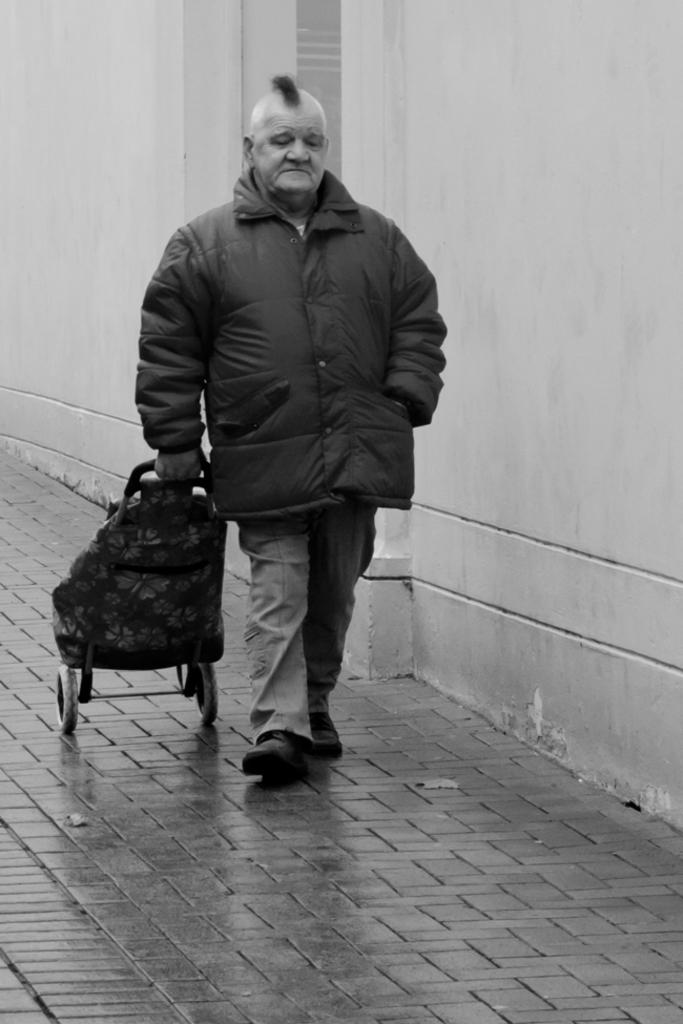What is the main subject of the image? There is a person standing in the center of the image. What is the person holding in the image? The person is holding a wheelchair. What can be seen in the background of the image? There is a wall in the background of the image. What type of mitten is the person wearing in the image? There is no mitten visible in the image; the person is holding a wheelchair. Is there a fire visible in the image? No, there is no fire present in the image. 